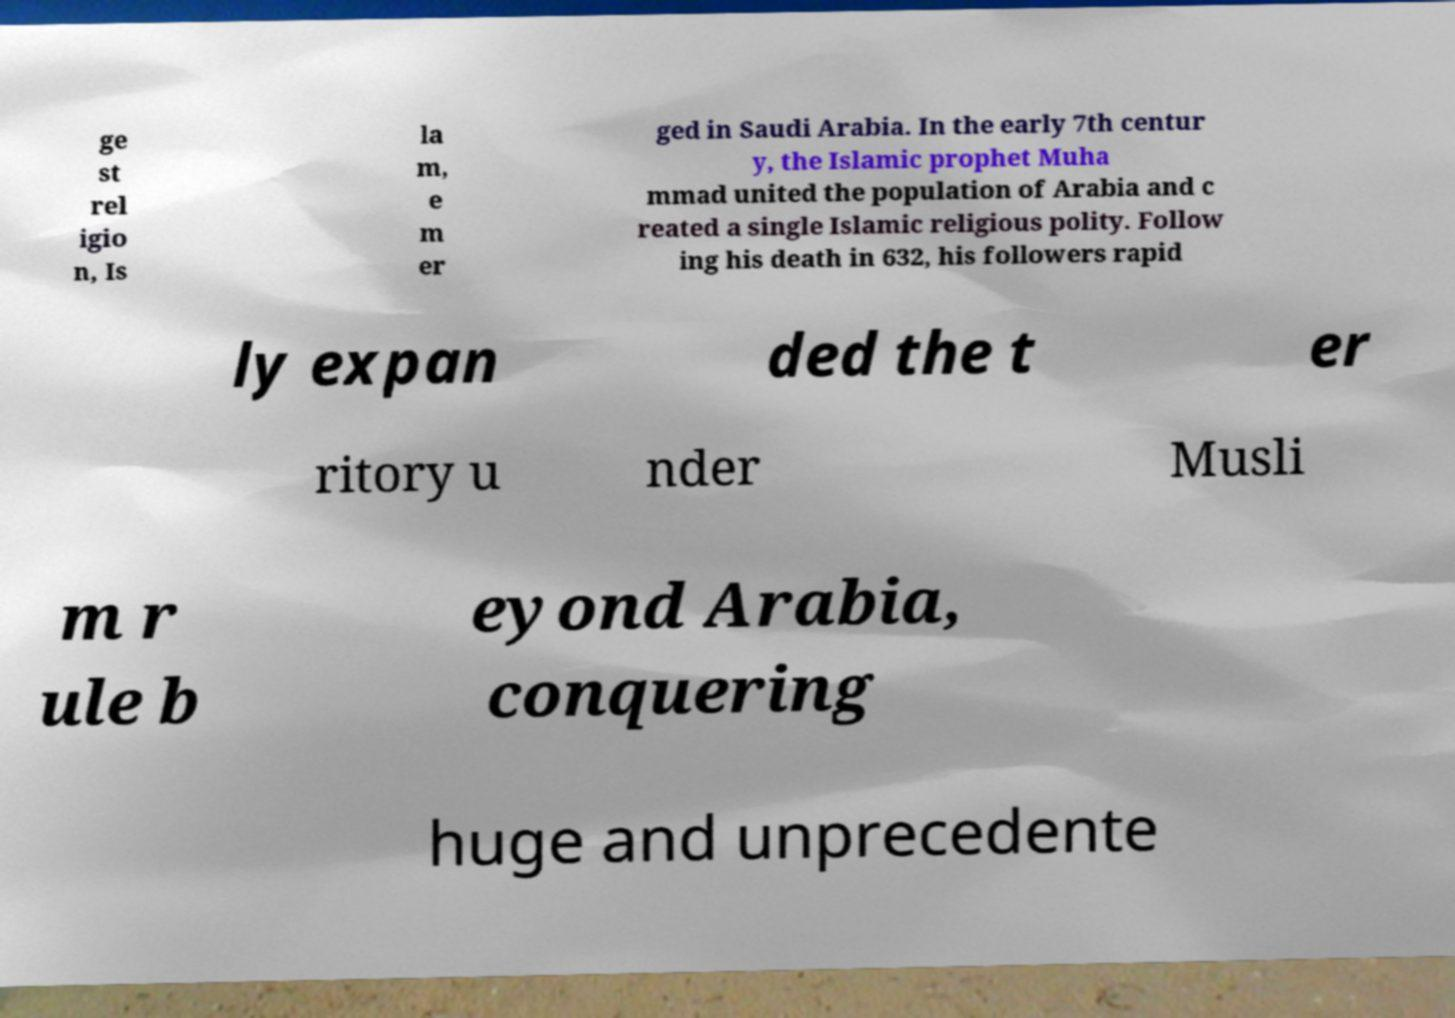I need the written content from this picture converted into text. Can you do that? ge st rel igio n, Is la m, e m er ged in Saudi Arabia. In the early 7th centur y, the Islamic prophet Muha mmad united the population of Arabia and c reated a single Islamic religious polity. Follow ing his death in 632, his followers rapid ly expan ded the t er ritory u nder Musli m r ule b eyond Arabia, conquering huge and unprecedente 